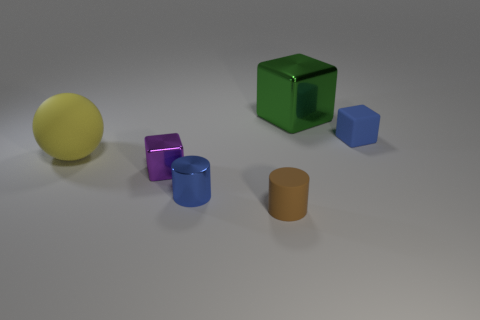Is there a metallic cylinder of the same color as the small matte block?
Offer a very short reply. Yes. How many balls are tiny purple metallic things or blue metallic objects?
Your answer should be very brief. 0. There is a tiny object on the right side of the big shiny thing; is its color the same as the large matte ball?
Give a very brief answer. No. What material is the tiny block to the left of the small matte object that is in front of the block that is on the left side of the small brown cylinder made of?
Provide a succinct answer. Metal. Is the green block the same size as the blue cylinder?
Give a very brief answer. No. There is a small metal cube; does it have the same color as the shiny cube that is behind the purple thing?
Keep it short and to the point. No. The small purple object that is the same material as the green object is what shape?
Make the answer very short. Cube. There is a small blue matte object behind the brown object; is its shape the same as the big yellow rubber thing?
Provide a succinct answer. No. There is a blue thing that is on the left side of the tiny thing that is behind the small purple block; how big is it?
Give a very brief answer. Small. What color is the small block that is made of the same material as the big yellow ball?
Offer a terse response. Blue. 